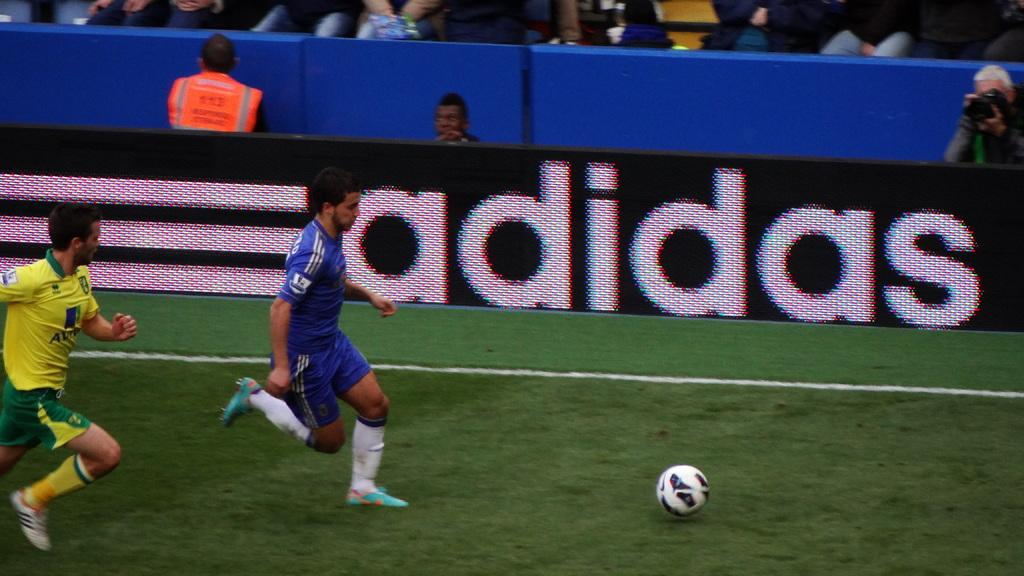<image>
Present a compact description of the photo's key features. the word Adidas that is on a black and white sign 